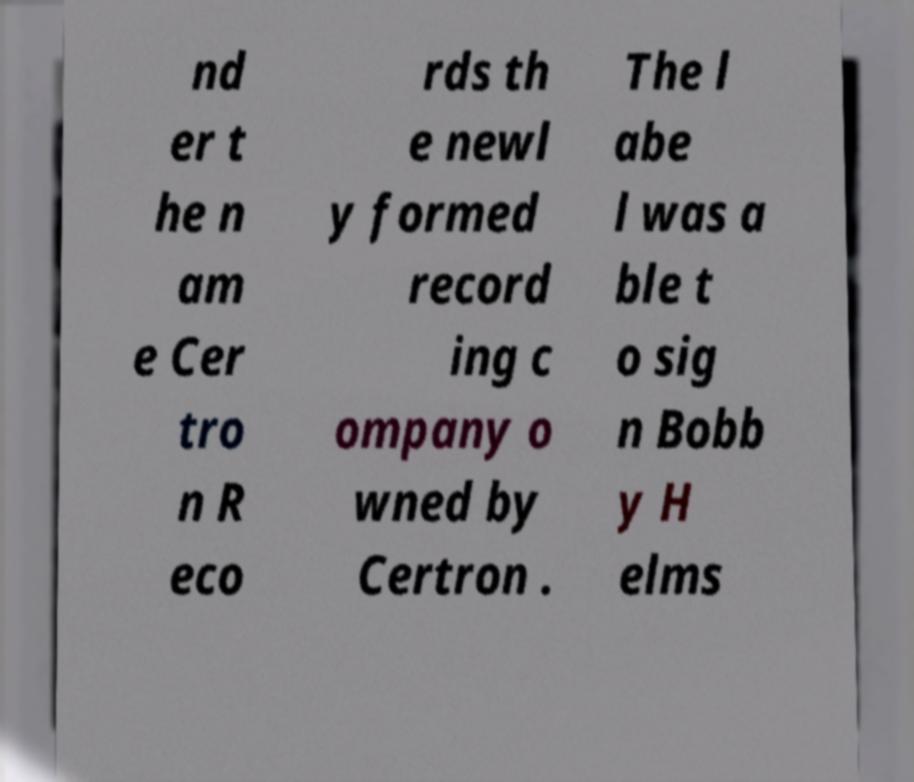I need the written content from this picture converted into text. Can you do that? nd er t he n am e Cer tro n R eco rds th e newl y formed record ing c ompany o wned by Certron . The l abe l was a ble t o sig n Bobb y H elms 